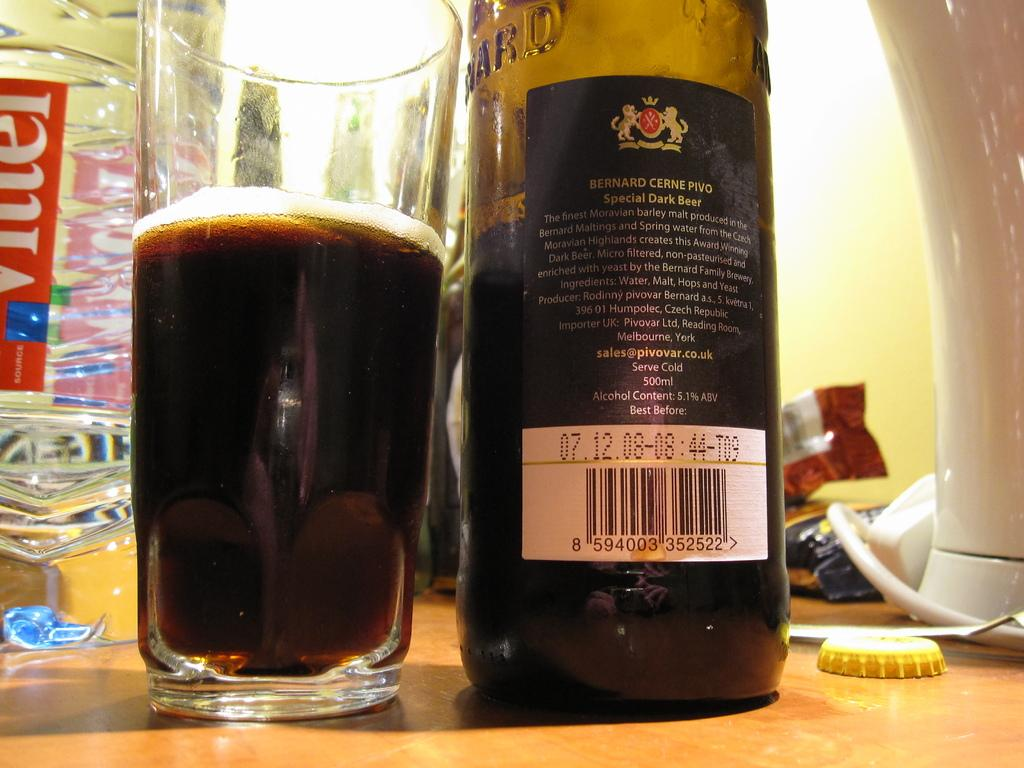What type of beverage container is in the image? There is a beer bottle in the image. What other type of container is in the image? There is a glass in the image. Are there any other beverage containers in the image? Yes, there is a water bottle in the image. Where are the beer bottle, glass, and water bottle located in the image? The beer bottle, glass, and water bottle are placed on a table. How many bikes are parked next to the table in the image? There are no bikes present in the image. What type of expert is shown giving a lecture in the image? There is no expert or lecture depicted in the image; it only features a table with a beer bottle, glass, and water bottle. 